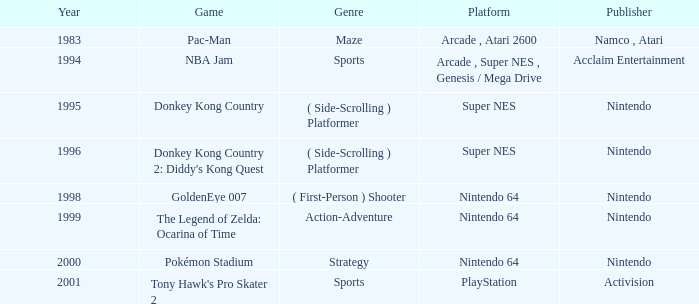Which Genre has a Year larger than 1999, and a Game of tony hawk's pro skater 2? Sports. 